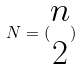<formula> <loc_0><loc_0><loc_500><loc_500>N = ( \begin{matrix} n \\ 2 \end{matrix} )</formula> 